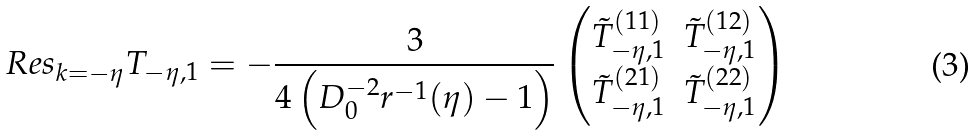Convert formula to latex. <formula><loc_0><loc_0><loc_500><loc_500>R e s _ { k = - \eta } T _ { - \eta , 1 } = - \frac { 3 } { 4 \left ( D _ { 0 } ^ { - 2 } r ^ { - 1 } ( \eta ) - 1 \right ) } \begin{pmatrix} \tilde { T } _ { - \eta , 1 } ^ { ( 1 1 ) } & \tilde { T } _ { - \eta , 1 } ^ { ( 1 2 ) } \\ \tilde { T } _ { - \eta , 1 } ^ { ( 2 1 ) } & \tilde { T } _ { - \eta , 1 } ^ { ( 2 2 ) } \end{pmatrix}</formula> 